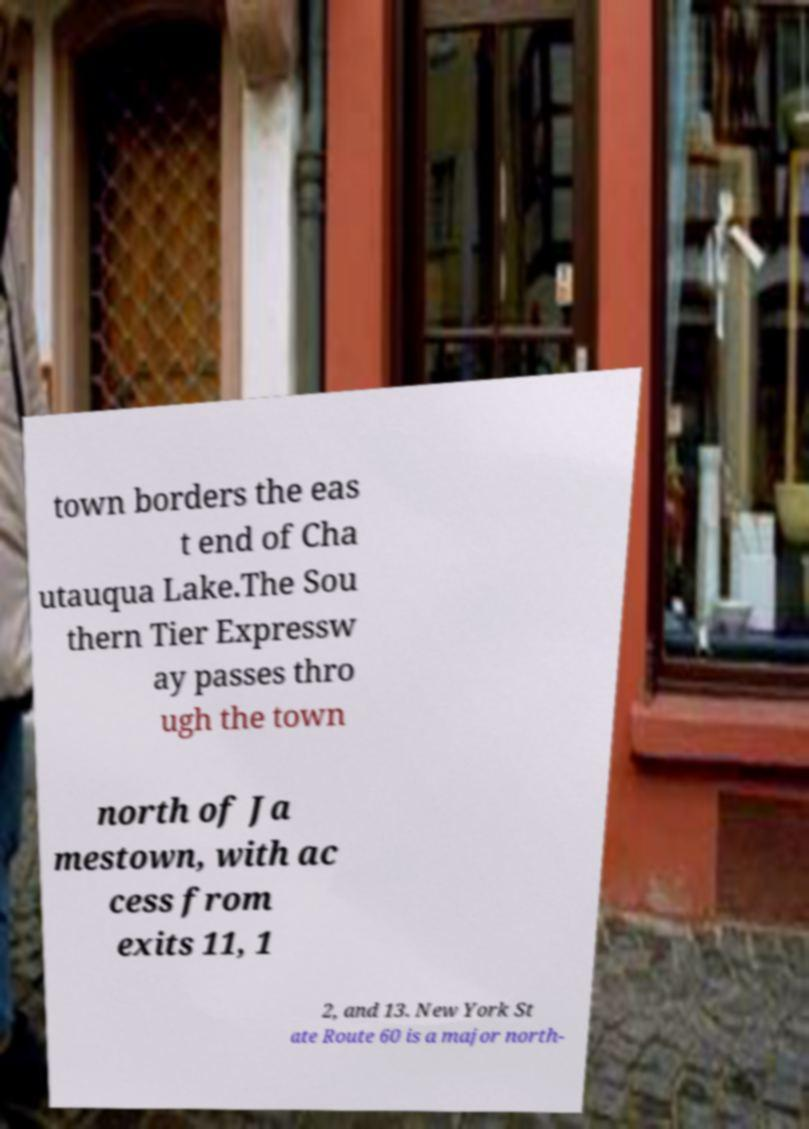Could you assist in decoding the text presented in this image and type it out clearly? town borders the eas t end of Cha utauqua Lake.The Sou thern Tier Expressw ay passes thro ugh the town north of Ja mestown, with ac cess from exits 11, 1 2, and 13. New York St ate Route 60 is a major north- 